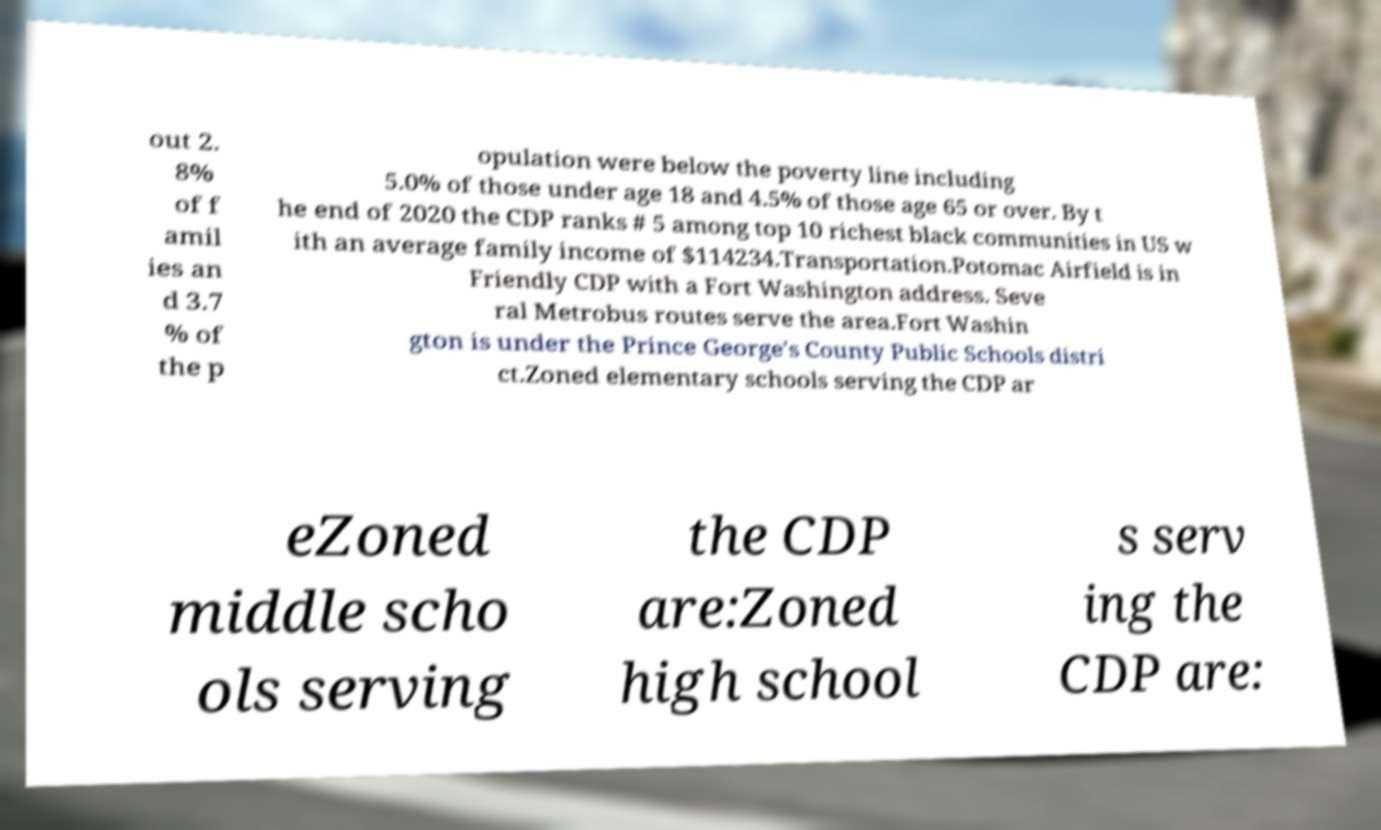For documentation purposes, I need the text within this image transcribed. Could you provide that? out 2. 8% of f amil ies an d 3.7 % of the p opulation were below the poverty line including 5.0% of those under age 18 and 4.5% of those age 65 or over. By t he end of 2020 the CDP ranks # 5 among top 10 richest black communities in US w ith an average family income of $114234.Transportation.Potomac Airfield is in Friendly CDP with a Fort Washington address. Seve ral Metrobus routes serve the area.Fort Washin gton is under the Prince George's County Public Schools distri ct.Zoned elementary schools serving the CDP ar eZoned middle scho ols serving the CDP are:Zoned high school s serv ing the CDP are: 